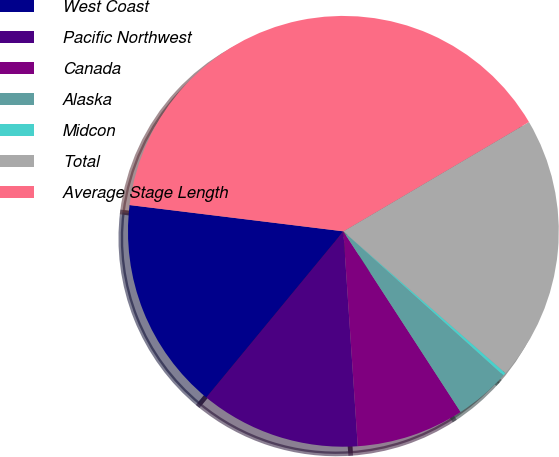<chart> <loc_0><loc_0><loc_500><loc_500><pie_chart><fcel>West Coast<fcel>Pacific Northwest<fcel>Canada<fcel>Alaska<fcel>Midcon<fcel>Total<fcel>Average Stage Length<nl><fcel>15.97%<fcel>12.04%<fcel>8.1%<fcel>4.17%<fcel>0.23%<fcel>19.91%<fcel>39.58%<nl></chart> 